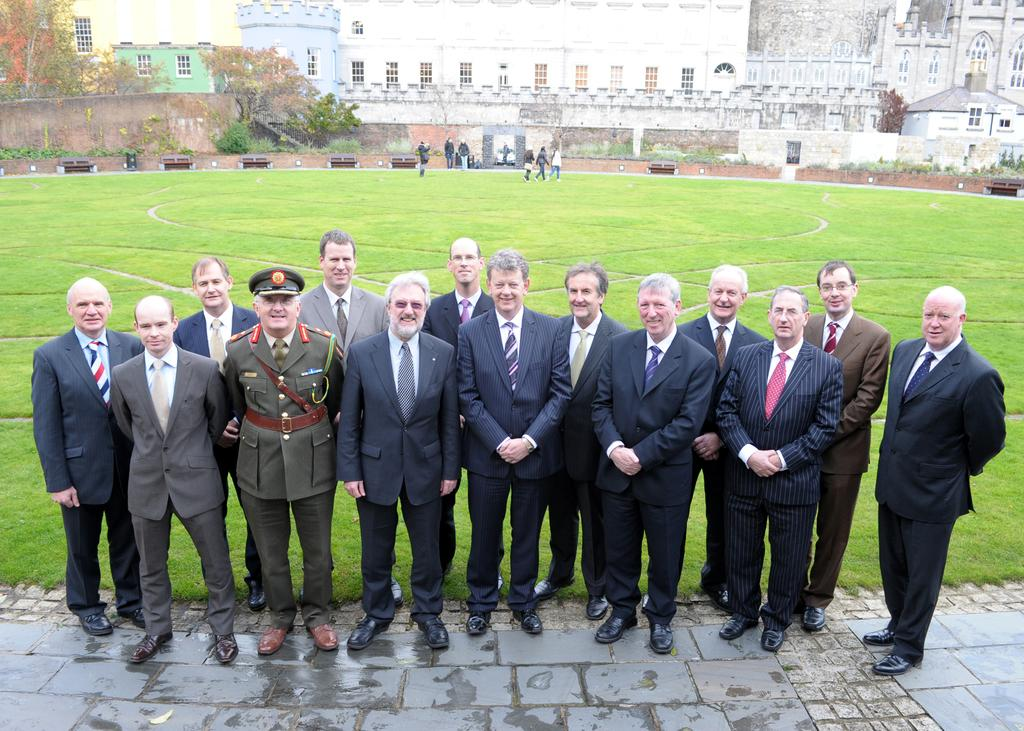What are the people in the image wearing? The people in the image are wearing suits. What is the terrain like in the image? The land is covered with grass. Can you see any other people in the image? Yes, there are people visible in the distance. What structures can be seen in the distance? There is a building with windows in the distance. What type of vegetation is visible in the distance? Plants and trees are visible in the distance. What type of gate is present in the image? There is no gate present in the image. How does the yoke compare to the people in the image? There is no yoke present in the image, so it cannot be compared to the people. 